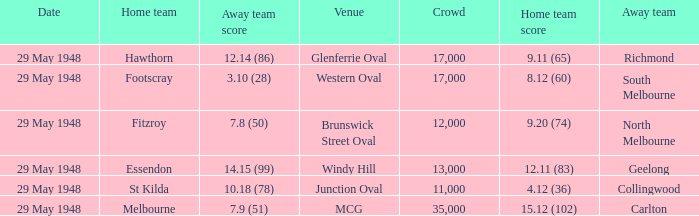In the match where footscray was the home team, how much did they score? 8.12 (60). Could you help me parse every detail presented in this table? {'header': ['Date', 'Home team', 'Away team score', 'Venue', 'Crowd', 'Home team score', 'Away team'], 'rows': [['29 May 1948', 'Hawthorn', '12.14 (86)', 'Glenferrie Oval', '17,000', '9.11 (65)', 'Richmond'], ['29 May 1948', 'Footscray', '3.10 (28)', 'Western Oval', '17,000', '8.12 (60)', 'South Melbourne'], ['29 May 1948', 'Fitzroy', '7.8 (50)', 'Brunswick Street Oval', '12,000', '9.20 (74)', 'North Melbourne'], ['29 May 1948', 'Essendon', '14.15 (99)', 'Windy Hill', '13,000', '12.11 (83)', 'Geelong'], ['29 May 1948', 'St Kilda', '10.18 (78)', 'Junction Oval', '11,000', '4.12 (36)', 'Collingwood'], ['29 May 1948', 'Melbourne', '7.9 (51)', 'MCG', '35,000', '15.12 (102)', 'Carlton']]} 